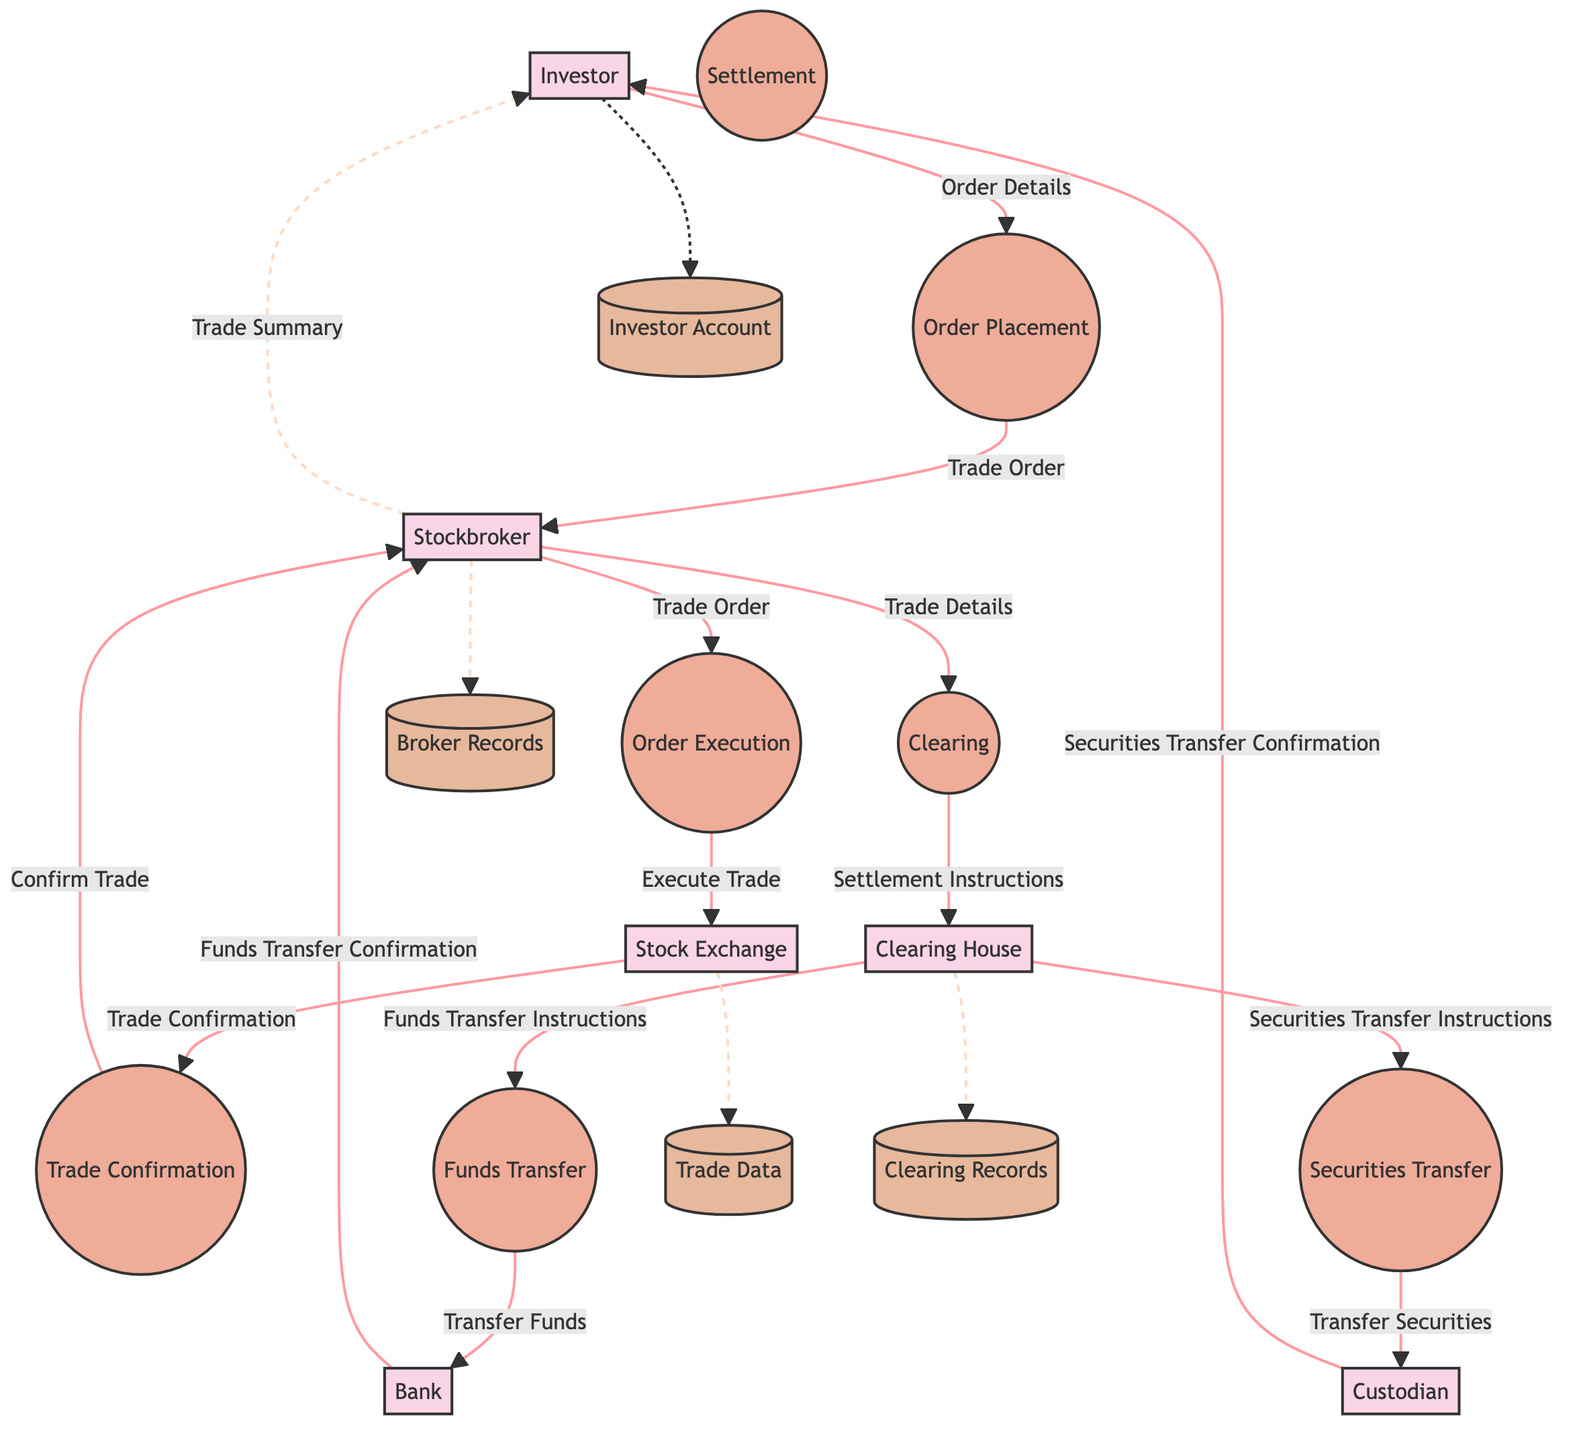What is the first process in the diagram? The diagram shows the flow starting from the Investor who places an order, which is labeled as Order Placement. Therefore, the first process is where the investor interacts by placing the order.
Answer: Order Placement How many entities are present in the diagram? The diagram lists six distinct entities: Investor, Stockbroker, Stock Exchange, Clearing House, Custodian, and Bank. Thus, the count of entities in the diagram is six.
Answer: Six What type of confirmation does the Stockbroker receive from the Stock Exchange? The flow from the Stock Exchange to the Stockbroker includes a data transfer labeled Trade Confirmation, which indicates the nature of the confirmation received.
Answer: Trade Confirmation Which entity receives the Securities Transfer Confirmation? As per the flow, after the Custodian completes the transfer of securities, it sends a Securities Transfer Confirmation to the Investor. Hence, the recipient is the Investor.
Answer: Investor In which process do funds get transferred? The process in which the funds are transferred is clearly marked as Funds Transfer in the diagram; this is where the respective bank handles the transfer of funds.
Answer: Funds Transfer What data flow occurs between the Clearing House and the Bank? The diagram shows a data flow from the Clearing House to the Bank labeled Funds Transfer Instructions. This indicates that the Clearing House provides the necessary instructions for the funds transfer process.
Answer: Funds Transfer Instructions Which process leads to the final transfer of securities? The Securities Transfer process is specifically indicated in the diagram as the step that leads to the actual transfer of securities to the buyer, following the clearing process.
Answer: Securities Transfer What is sent from the Custodian to the Investor after the transaction? The Custodian issues a Securities Transfer Confirmation, which returns the details of the transferred securities back to the Investor after the transaction is completed.
Answer: Securities Transfer Confirmation What does the Stockbroker provide to the Investor at the end of the process? The Stockbroker concludes the transaction by providing a Trade Summary to the Investor, which summarizes the executed and settled trade details for the investor's records.
Answer: Trade Summary 